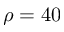<formula> <loc_0><loc_0><loc_500><loc_500>\rho = 4 0</formula> 